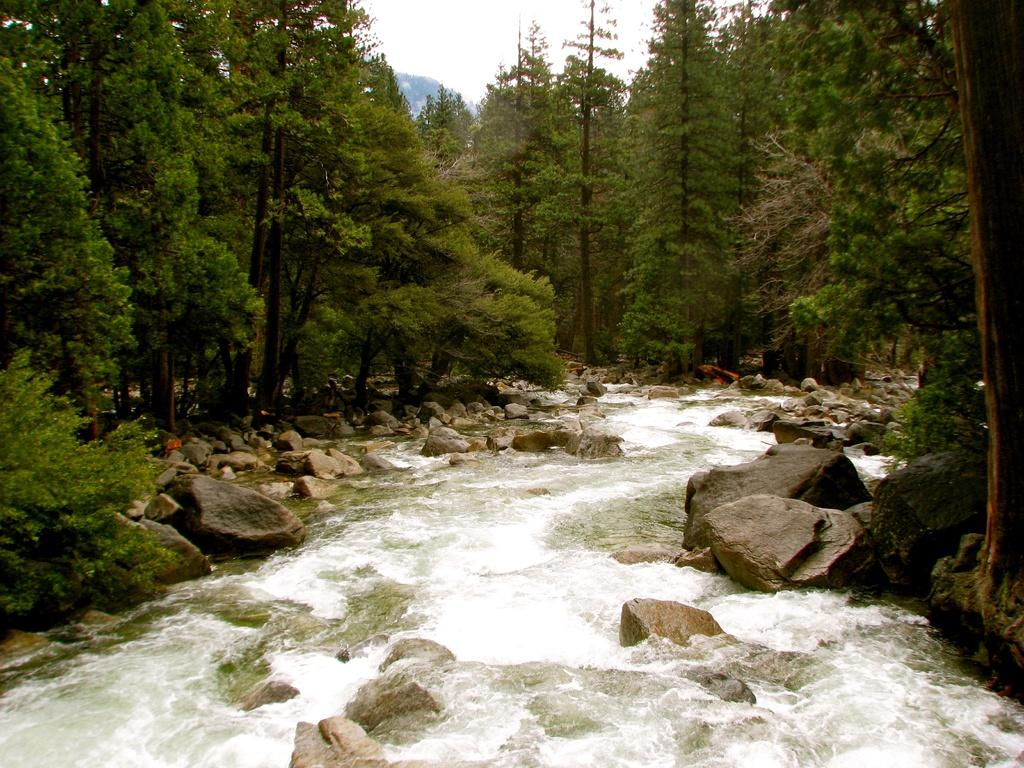What type of natural feature is at the bottom of the image? There is a river at the bottom of the image. What can be found on the right side of the image? There are stones and rocks, as well as trees, on the right side of the image. What is present on the left side of the image? There are also stones and rocks, as well as trees, on the left side of the image. What is visible at the top of the image? The sky is visible at the top of the image. How does the queen interact with the secretary in the image? There is no queen, nor any secretary, present in the image. 